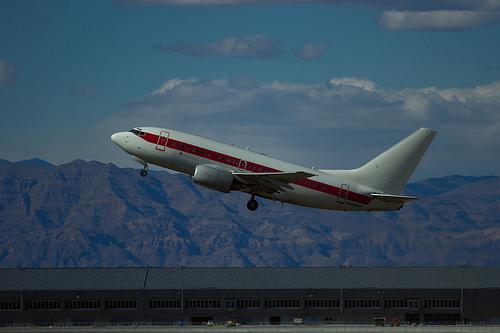Explain what action the main subject seems to be performing in the image. The airplane appears to be taking off, pointing towards the sky with its landing gear down. Mention a significant detail about the airplane's tail. The tail of the airplane is white, with a red stripe running across the plane's body. What is the most noticeable feature of the building below the airplane? The building has many windows and possibly a grey roof. What type of building is visible on the ground in the image? A long building, possibly part of an airport, with many windows. Describe the state of the airplane's landing gear. The landing gear is down, with the front wheel visible near the plane's nose. Describe the position of the airplane's engine relative to the wing. The engine is located beneath the left wing of the airplane. Identify the primary object in the image and mention its most prominent feature. The main object is an airplane with a red and white color scheme and many windows. What time of day does the image seem to depict? The image appears to be taken during the daytime. Describe the natural elements present in the image's background. There are mountains, clouds in the sky, and a partially cloudy atmosphere. Point out any vehicles that can be seen on the ground. There are some cars visible on the ground near the long building. 